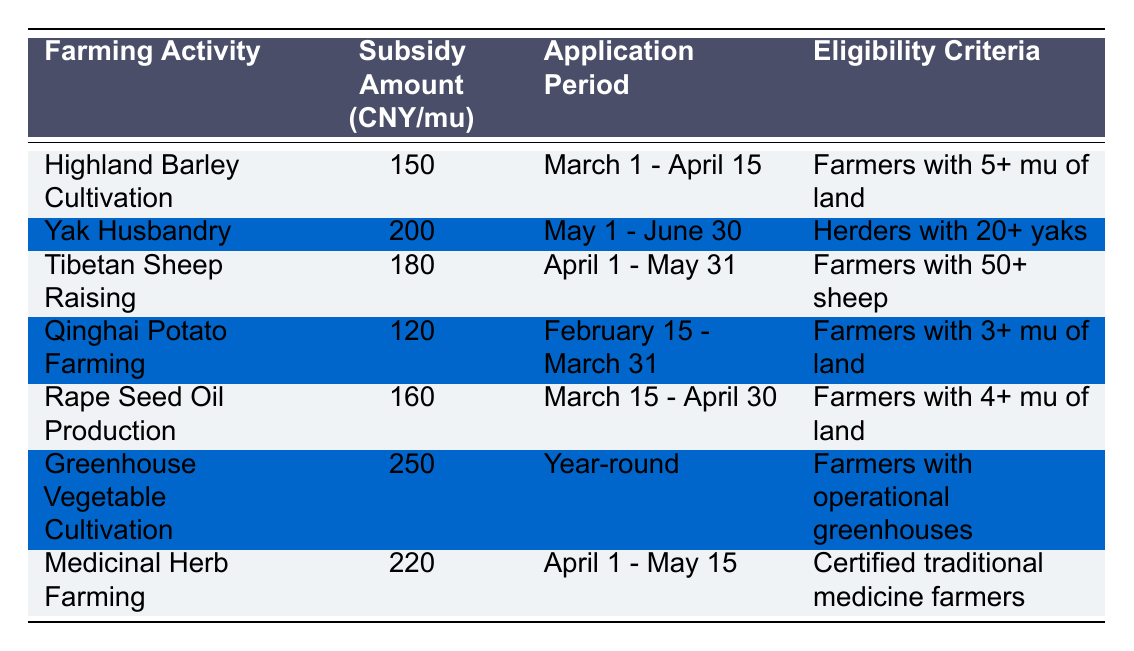What farming activity has the highest subsidy amount? By looking at the "Subsidy Amount (CNY/mu)" column, we can see that "Greenhouse Vegetable Cultivation" has the highest subsidy amount of 250 CNY/mu.
Answer: Greenhouse Vegetable Cultivation How much subsidy is available for Qinghai Potato Farming? The table lists the subsidy amount for "Qinghai Potato Farming" as 120 CNY/mu.
Answer: 120 CNY/mu What is the application period for Yak Husbandry? The application period for "Yak Husbandry" is stated in the table as "May 1 - June 30".
Answer: May 1 - June 30 Are farmers with less than 5 mu of land eligible for Highland Barley Cultivation subsidies? According to the eligibility criteria for "Highland Barley Cultivation", farmers need to have 5+ mu of land, meaning those with less than 5 mu are not eligible.
Answer: No What is the difference in subsidy amounts between Medicinal Herb Farming and Rape Seed Oil Production? The subsidy for "Medicinal Herb Farming" is 220 CNY/mu and for "Rape Seed Oil Production" it is 160 CNY/mu. The difference is 220 - 160 = 60.
Answer: 60 CNY/mu What is the eligibility criterion for Greenhouse Vegetable Cultivation? The eligibility criterion listed for "Greenhouse Vegetable Cultivation" is that farmers must have operational greenhouses.
Answer: Farmers with operational greenhouses How many farming activities have a subsidy of over 200 CNY/mu? From the table, we identify "Yak Husbandry" (200 CNY/mu), "Medicinal Herb Farming" (220 CNY/mu), and "Greenhouse Vegetable Cultivation" (250 CNY/mu), which gives us 3 activities with subsidies over 200 CNY/mu.
Answer: 3 